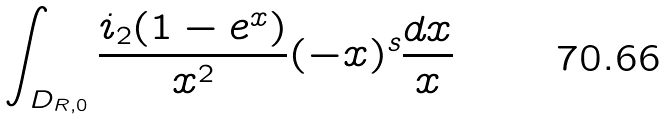Convert formula to latex. <formula><loc_0><loc_0><loc_500><loc_500>\int _ { D _ { R , 0 } } \frac { \L i _ { 2 } ( 1 - e ^ { x } ) } { x ^ { 2 } } ( - x ) ^ { s } \frac { d x } { x }</formula> 